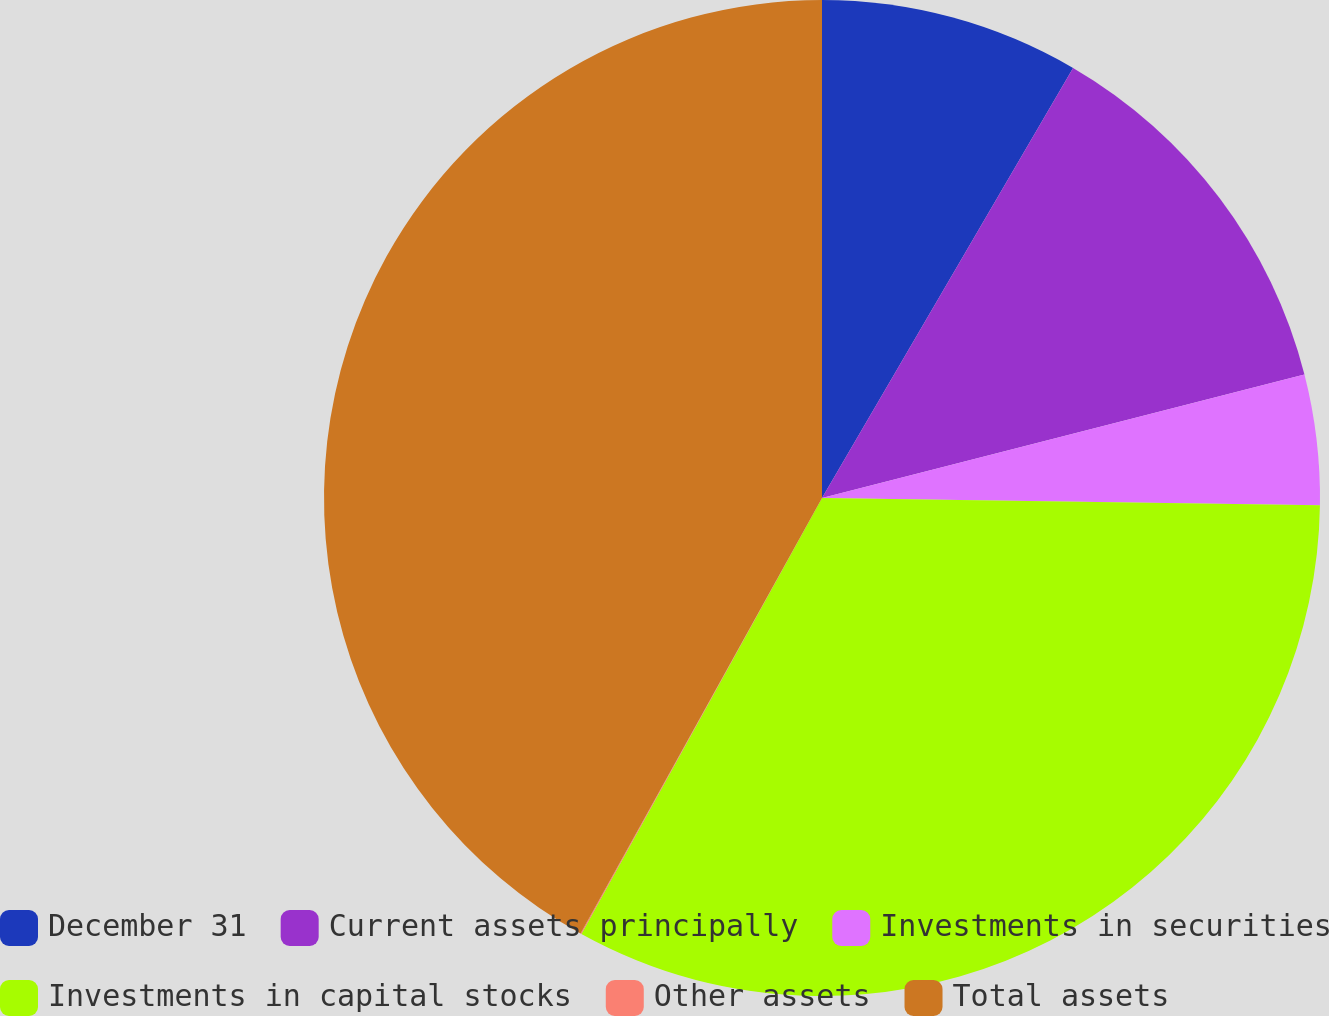<chart> <loc_0><loc_0><loc_500><loc_500><pie_chart><fcel>December 31<fcel>Current assets principally<fcel>Investments in securities<fcel>Investments in capital stocks<fcel>Other assets<fcel>Total assets<nl><fcel>8.41%<fcel>12.6%<fcel>4.22%<fcel>32.79%<fcel>0.03%<fcel>41.94%<nl></chart> 